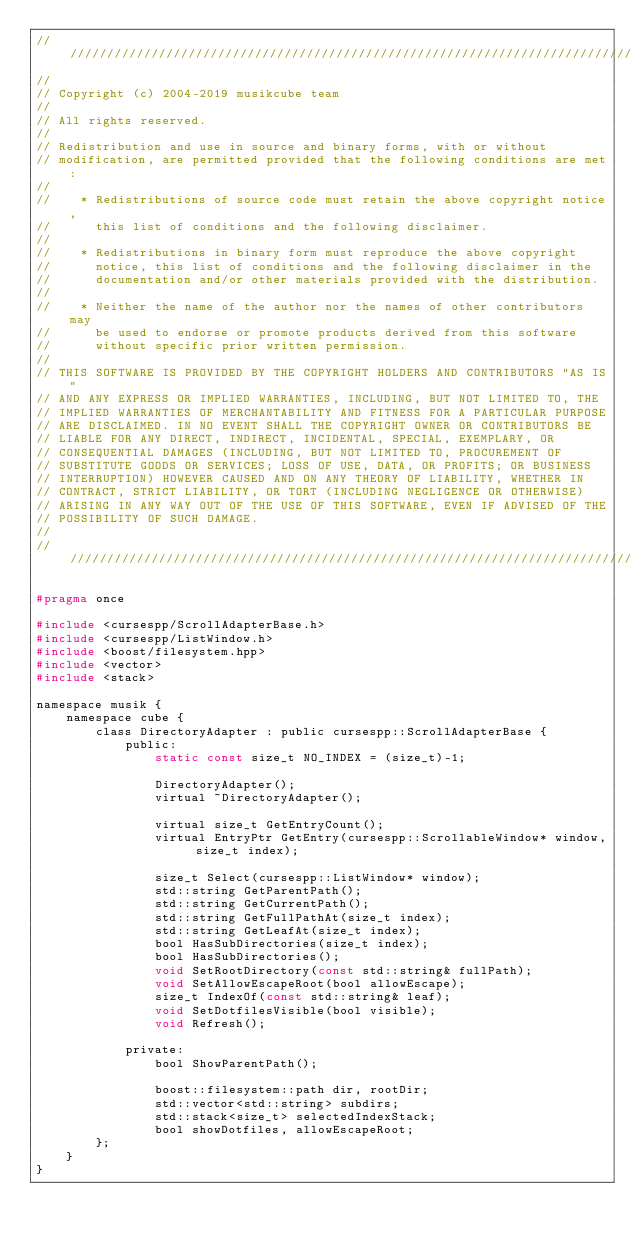<code> <loc_0><loc_0><loc_500><loc_500><_C_>//////////////////////////////////////////////////////////////////////////////
//
// Copyright (c) 2004-2019 musikcube team
//
// All rights reserved.
//
// Redistribution and use in source and binary forms, with or without
// modification, are permitted provided that the following conditions are met:
//
//    * Redistributions of source code must retain the above copyright notice,
//      this list of conditions and the following disclaimer.
//
//    * Redistributions in binary form must reproduce the above copyright
//      notice, this list of conditions and the following disclaimer in the
//      documentation and/or other materials provided with the distribution.
//
//    * Neither the name of the author nor the names of other contributors may
//      be used to endorse or promote products derived from this software
//      without specific prior written permission.
//
// THIS SOFTWARE IS PROVIDED BY THE COPYRIGHT HOLDERS AND CONTRIBUTORS "AS IS"
// AND ANY EXPRESS OR IMPLIED WARRANTIES, INCLUDING, BUT NOT LIMITED TO, THE
// IMPLIED WARRANTIES OF MERCHANTABILITY AND FITNESS FOR A PARTICULAR PURPOSE
// ARE DISCLAIMED. IN NO EVENT SHALL THE COPYRIGHT OWNER OR CONTRIBUTORS BE
// LIABLE FOR ANY DIRECT, INDIRECT, INCIDENTAL, SPECIAL, EXEMPLARY, OR
// CONSEQUENTIAL DAMAGES (INCLUDING, BUT NOT LIMITED TO, PROCUREMENT OF
// SUBSTITUTE GOODS OR SERVICES; LOSS OF USE, DATA, OR PROFITS; OR BUSINESS
// INTERRUPTION) HOWEVER CAUSED AND ON ANY THEORY OF LIABILITY, WHETHER IN
// CONTRACT, STRICT LIABILITY, OR TORT (INCLUDING NEGLIGENCE OR OTHERWISE)
// ARISING IN ANY WAY OUT OF THE USE OF THIS SOFTWARE, EVEN IF ADVISED OF THE
// POSSIBILITY OF SUCH DAMAGE.
//
//////////////////////////////////////////////////////////////////////////////

#pragma once

#include <cursespp/ScrollAdapterBase.h>
#include <cursespp/ListWindow.h>
#include <boost/filesystem.hpp>
#include <vector>
#include <stack>

namespace musik {
    namespace cube {
        class DirectoryAdapter : public cursespp::ScrollAdapterBase {
            public:
                static const size_t NO_INDEX = (size_t)-1;

                DirectoryAdapter();
                virtual ~DirectoryAdapter();

                virtual size_t GetEntryCount();
                virtual EntryPtr GetEntry(cursespp::ScrollableWindow* window, size_t index);

                size_t Select(cursespp::ListWindow* window);
                std::string GetParentPath();
                std::string GetCurrentPath();
                std::string GetFullPathAt(size_t index);
                std::string GetLeafAt(size_t index);
                bool HasSubDirectories(size_t index);
                bool HasSubDirectories();
                void SetRootDirectory(const std::string& fullPath);
                void SetAllowEscapeRoot(bool allowEscape);
                size_t IndexOf(const std::string& leaf);
                void SetDotfilesVisible(bool visible);
                void Refresh();

            private:
                bool ShowParentPath();

                boost::filesystem::path dir, rootDir;
                std::vector<std::string> subdirs;
                std::stack<size_t> selectedIndexStack;
                bool showDotfiles, allowEscapeRoot;
        };
    }
}
</code> 